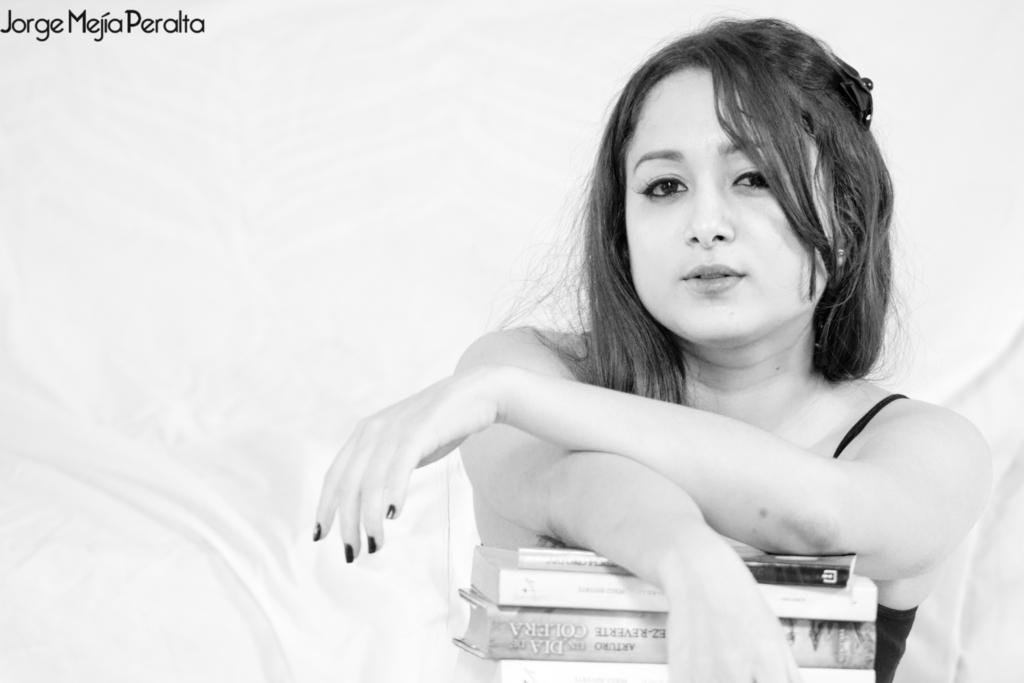What is the color scheme of the image? The image is black and white. What is the person in the image doing? The person is sitting on a chair in the image. What objects are in front of the person? There are books in front of the person. What type of ghost can be seen interacting with the books in the image? There is no ghost present in the image; it features a person sitting on a chair with books in front of them. What system was used to create the black and white effect in the image? The facts provided do not mention any specific system used to create the black and white effect in the image. 